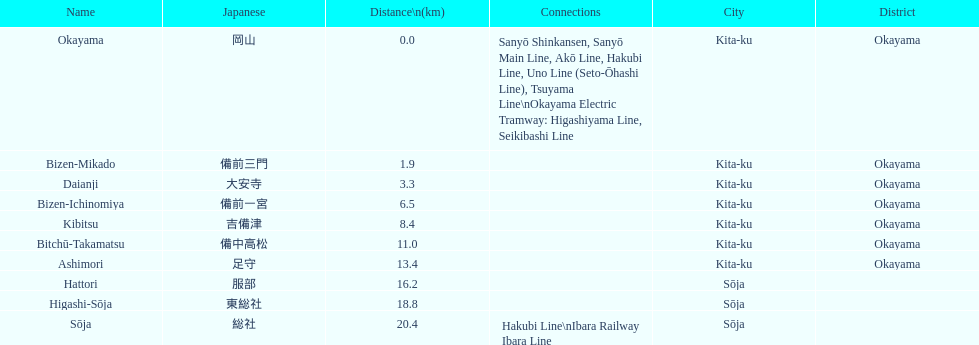How many stations have a distance below 15km? 7. 